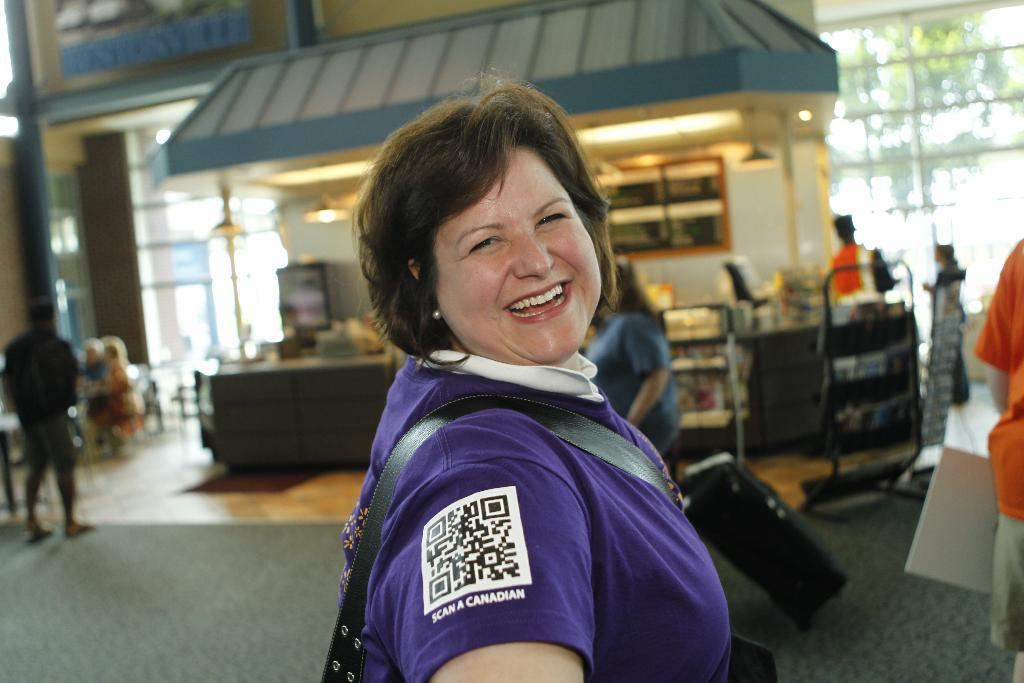How many people are in the image? There are people in the image, but the exact number is not specified. What are the people holding in the image? One person is holding a bag, and another person is holding a board. What type of structure is visible in the image? There is a shed in the image. What architectural features can be seen in the image? There are windows and a wall visible in the image. How many cats are sitting on the windowsill in the image? There are no cats present in the image. What type of reward is being given to the pigs in the image? There are no pigs present in the image, and therefore no rewards are being given. 